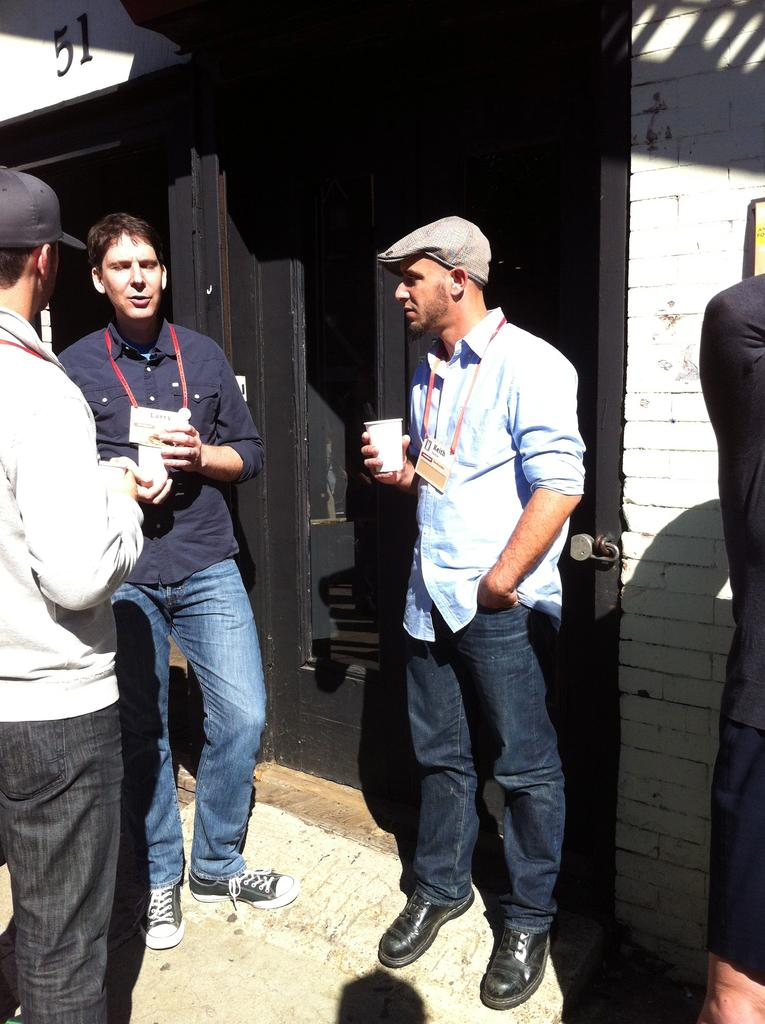How many people are in the image? There is a group of people in the image. What are the people doing in the image? The people are standing on the ground. What are two of the people holding? Two men are holding glasses. What can be seen in the background of the image? There is a building in the background of the image. What feature of the building is mentioned? The building has a door. What type of poison is being served in the glasses held by the two men in the image? There is no indication of poison in the image; the glasses are likely holding a beverage. Can you describe the clouds in the image? There are no clouds visible in the image; the image only shows a group of people, two men holding glasses, and a building in the background. 